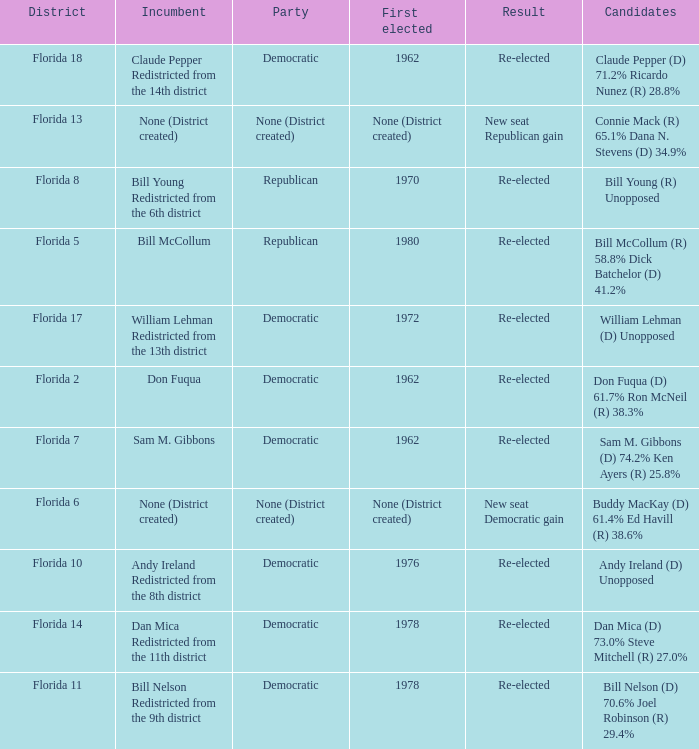Who is the the candidates with incumbent being don fuqua Don Fuqua (D) 61.7% Ron McNeil (R) 38.3%. Can you give me this table as a dict? {'header': ['District', 'Incumbent', 'Party', 'First elected', 'Result', 'Candidates'], 'rows': [['Florida 18', 'Claude Pepper Redistricted from the 14th district', 'Democratic', '1962', 'Re-elected', 'Claude Pepper (D) 71.2% Ricardo Nunez (R) 28.8%'], ['Florida 13', 'None (District created)', 'None (District created)', 'None (District created)', 'New seat Republican gain', 'Connie Mack (R) 65.1% Dana N. Stevens (D) 34.9%'], ['Florida 8', 'Bill Young Redistricted from the 6th district', 'Republican', '1970', 'Re-elected', 'Bill Young (R) Unopposed'], ['Florida 5', 'Bill McCollum', 'Republican', '1980', 'Re-elected', 'Bill McCollum (R) 58.8% Dick Batchelor (D) 41.2%'], ['Florida 17', 'William Lehman Redistricted from the 13th district', 'Democratic', '1972', 'Re-elected', 'William Lehman (D) Unopposed'], ['Florida 2', 'Don Fuqua', 'Democratic', '1962', 'Re-elected', 'Don Fuqua (D) 61.7% Ron McNeil (R) 38.3%'], ['Florida 7', 'Sam M. Gibbons', 'Democratic', '1962', 'Re-elected', 'Sam M. Gibbons (D) 74.2% Ken Ayers (R) 25.8%'], ['Florida 6', 'None (District created)', 'None (District created)', 'None (District created)', 'New seat Democratic gain', 'Buddy MacKay (D) 61.4% Ed Havill (R) 38.6%'], ['Florida 10', 'Andy Ireland Redistricted from the 8th district', 'Democratic', '1976', 'Re-elected', 'Andy Ireland (D) Unopposed'], ['Florida 14', 'Dan Mica Redistricted from the 11th district', 'Democratic', '1978', 'Re-elected', 'Dan Mica (D) 73.0% Steve Mitchell (R) 27.0%'], ['Florida 11', 'Bill Nelson Redistricted from the 9th district', 'Democratic', '1978', 'Re-elected', 'Bill Nelson (D) 70.6% Joel Robinson (R) 29.4%']]} 